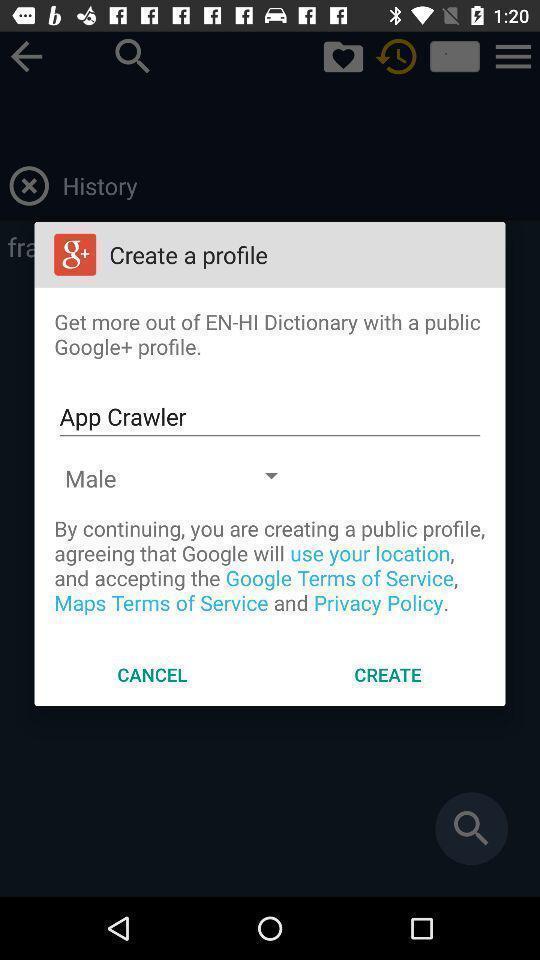Provide a detailed account of this screenshot. Pop-up showing the create profile notification. 